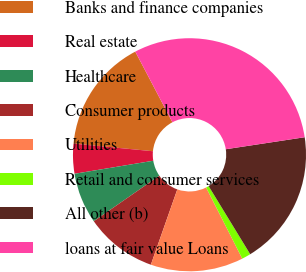Convert chart. <chart><loc_0><loc_0><loc_500><loc_500><pie_chart><fcel>Banks and finance companies<fcel>Real estate<fcel>Healthcare<fcel>Consumer products<fcel>Utilities<fcel>Retail and consumer services<fcel>All other (b)<fcel>loans at fair value Loans<nl><fcel>15.77%<fcel>4.14%<fcel>7.05%<fcel>9.96%<fcel>12.86%<fcel>1.24%<fcel>18.68%<fcel>30.3%<nl></chart> 